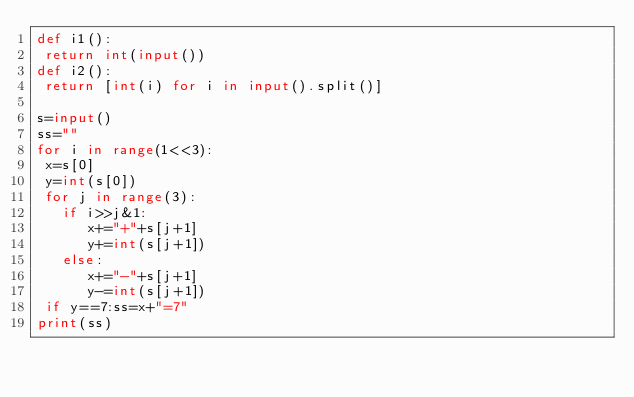Convert code to text. <code><loc_0><loc_0><loc_500><loc_500><_Python_>def i1():
 return int(input())
def i2():
 return [int(i) for i in input().split()]

s=input()
ss=""
for i in range(1<<3):
 x=s[0]
 y=int(s[0])
 for j in range(3):
   if i>>j&1:
      x+="+"+s[j+1]
      y+=int(s[j+1])
   else:
      x+="-"+s[j+1]
      y-=int(s[j+1])
 if y==7:ss=x+"=7"
print(ss)</code> 